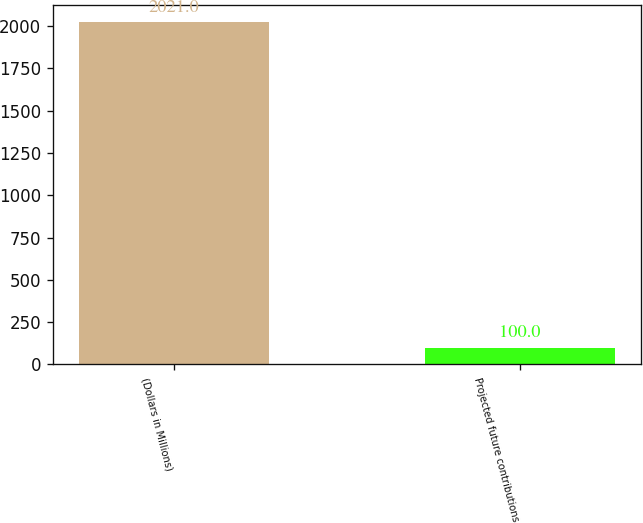Convert chart to OTSL. <chart><loc_0><loc_0><loc_500><loc_500><bar_chart><fcel>(Dollars in Millions)<fcel>Projected future contributions<nl><fcel>2021<fcel>100<nl></chart> 